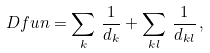<formula> <loc_0><loc_0><loc_500><loc_500>\ D f u n = \sum _ { k } \, \frac { 1 } { d _ { k } } + \sum _ { k l } \, \frac { 1 } { d _ { k l } } \, ,</formula> 